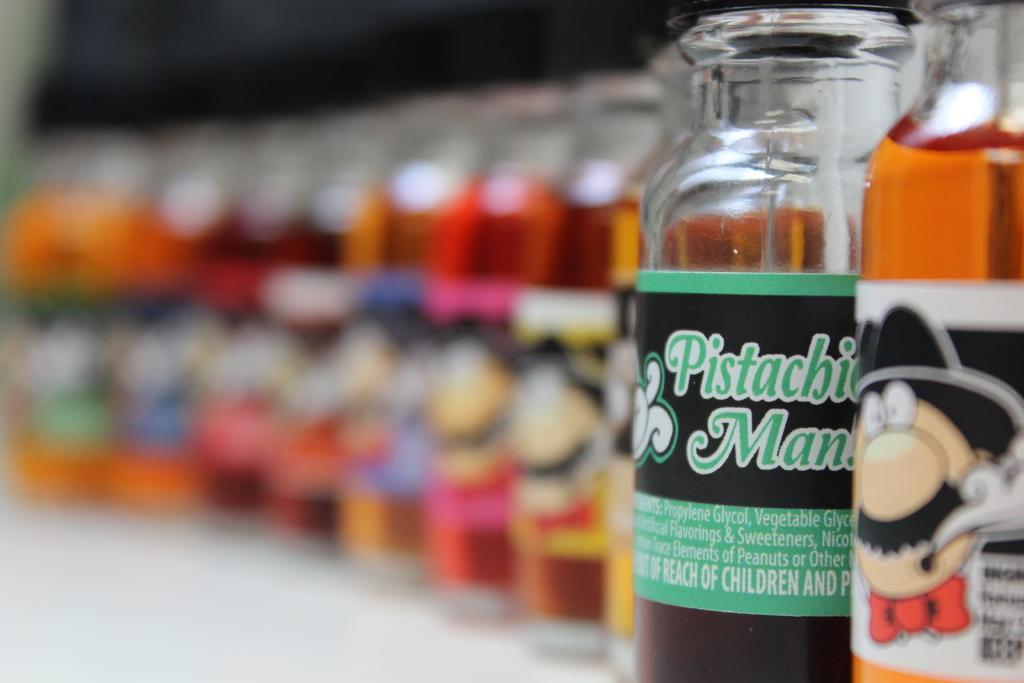Can you describe this image briefly? In this image I see number of bottles and on the bottles I see an animation character. 